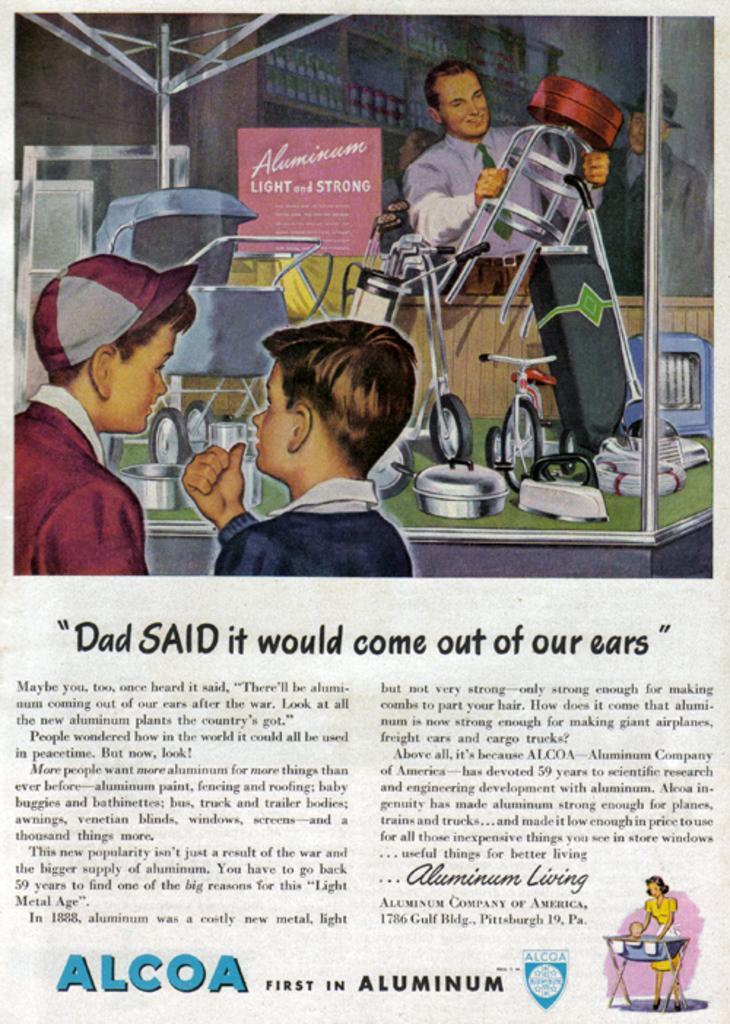Describe this image in one or two sentences. This picture might be painting in the article. In this image, we can see three people and some metal instrument, we can also see some text written in the article. 